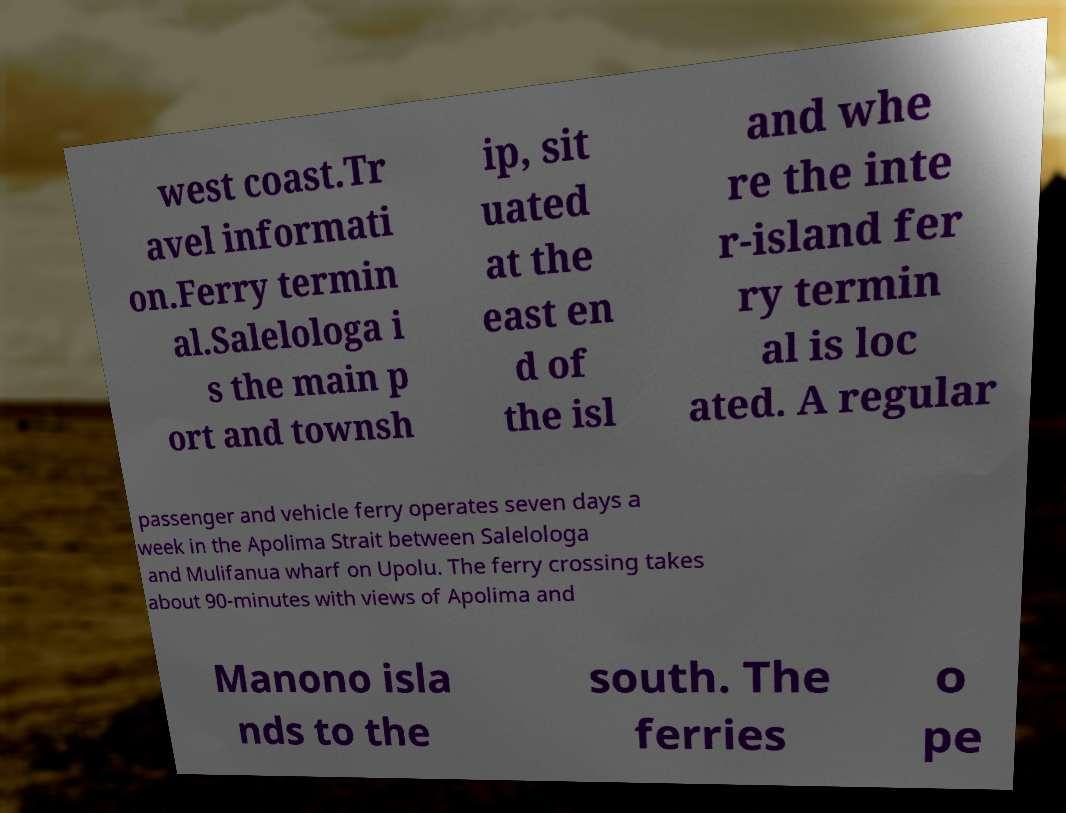What messages or text are displayed in this image? I need them in a readable, typed format. west coast.Tr avel informati on.Ferry termin al.Salelologa i s the main p ort and townsh ip, sit uated at the east en d of the isl and whe re the inte r-island fer ry termin al is loc ated. A regular passenger and vehicle ferry operates seven days a week in the Apolima Strait between Salelologa and Mulifanua wharf on Upolu. The ferry crossing takes about 90-minutes with views of Apolima and Manono isla nds to the south. The ferries o pe 